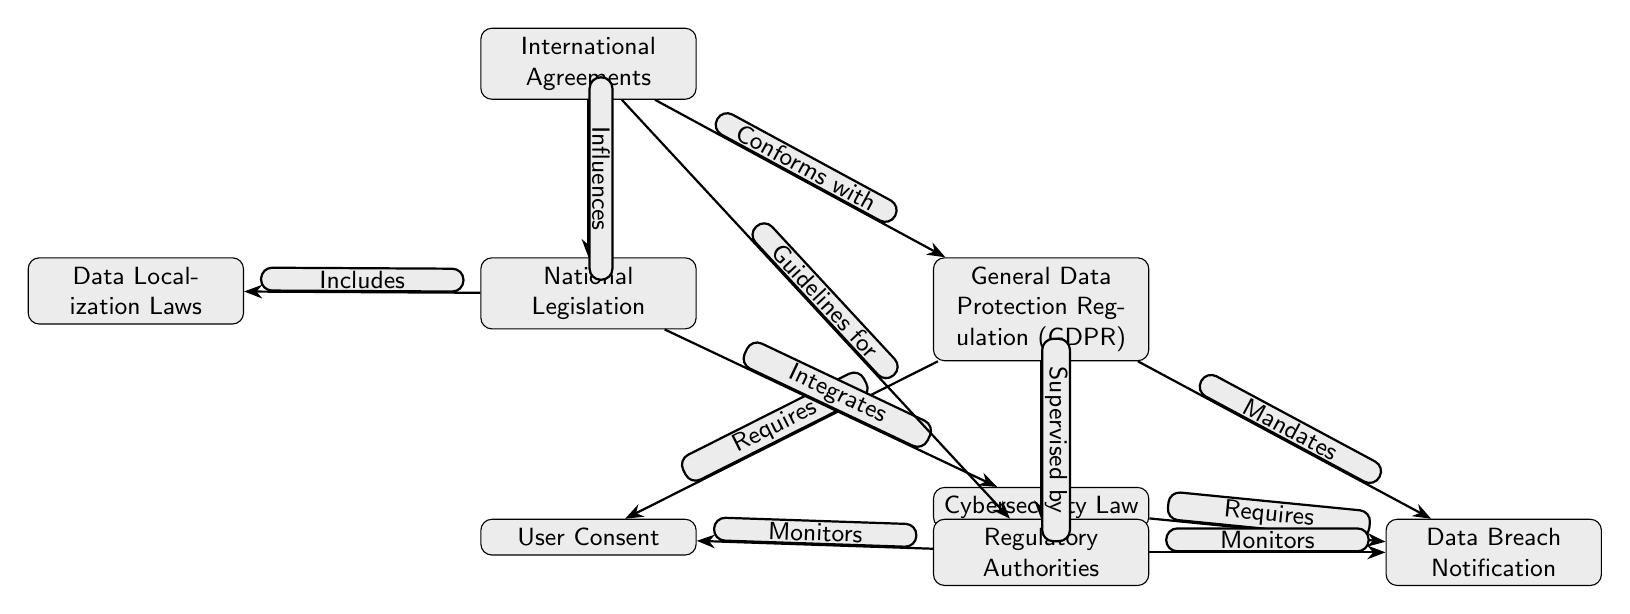What is the top node in the diagram? The top node is labeled "International Agreements," which is positioned at the top of the diagram, serving as the main source of influence for the other components.
Answer: International Agreements How many nodes are connected to the "General Data Protection Regulation (GDPR)"? The "General Data Protection Regulation (GDPR)" node has three connections to the nodes "User Consent," "Data Breach Notification," and "Regulatory Authorities," indicating the aspects it addresses.
Answer: 3 What does the "National Legislation" include? The "National Legislation" node has a direct connection labeled "Includes" to the "Data Localization Laws," indicating that these laws are a part of National Legislation.
Answer: Data Localization Laws Which two nodes are connected by the edge labeled "Mandates"? The edge labeled "Mandates" connects "General Data Protection Regulation (GDPR)" to "Data Breach Notification," showing that GDPR requires this specific action.
Answer: Data Breach Notification How do "International Agreements" and "National Legislation" interact according to the diagram? "International Agreements" influences "National Legislation," as shown by their connecting edge labeled "Influences," which indicates that international standards and agreements shape national laws.
Answer: Influences What role do "Regulatory Authorities" have regarding "User Consent" in the diagram? The "Regulatory Authorities" node has an edge labeled "Monitors" pointing to "User Consent," indicating that the authorities oversee or ensure compliance with consent regulations under GDPR.
Answer: Monitors Name one type of law that is integrated into "National Legislation". The node "Cybersecurity Law," connected with an edge labeled "Integrates," indicates its inclusion within the broader framework of National Legislation.
Answer: Cybersecurity Law Which node requires "Data Breach Notification" as indicated in the diagram? The node "General Data Protection Regulation (GDPR)" has an edge labeled "Mandates" connecting it to "Data Breach Notification," indicating that GDPR requires this notification process.
Answer: GDPR What is the relationship between "Cybersecurity Law" and "Data Breach Notification"? "Cybersecurity Law" has an edge labeled "Requires" connecting to "Data Breach Notification," which indicates that compliance with cybersecurity regulations necessitates notifying users about data breaches.
Answer: Requires 